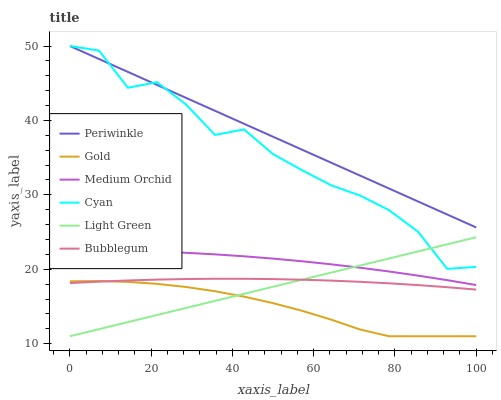Does Gold have the minimum area under the curve?
Answer yes or no. Yes. Does Periwinkle have the maximum area under the curve?
Answer yes or no. Yes. Does Medium Orchid have the minimum area under the curve?
Answer yes or no. No. Does Medium Orchid have the maximum area under the curve?
Answer yes or no. No. Is Light Green the smoothest?
Answer yes or no. Yes. Is Cyan the roughest?
Answer yes or no. Yes. Is Medium Orchid the smoothest?
Answer yes or no. No. Is Medium Orchid the roughest?
Answer yes or no. No. Does Gold have the lowest value?
Answer yes or no. Yes. Does Medium Orchid have the lowest value?
Answer yes or no. No. Does Cyan have the highest value?
Answer yes or no. Yes. Does Medium Orchid have the highest value?
Answer yes or no. No. Is Light Green less than Periwinkle?
Answer yes or no. Yes. Is Cyan greater than Medium Orchid?
Answer yes or no. Yes. Does Light Green intersect Bubblegum?
Answer yes or no. Yes. Is Light Green less than Bubblegum?
Answer yes or no. No. Is Light Green greater than Bubblegum?
Answer yes or no. No. Does Light Green intersect Periwinkle?
Answer yes or no. No. 